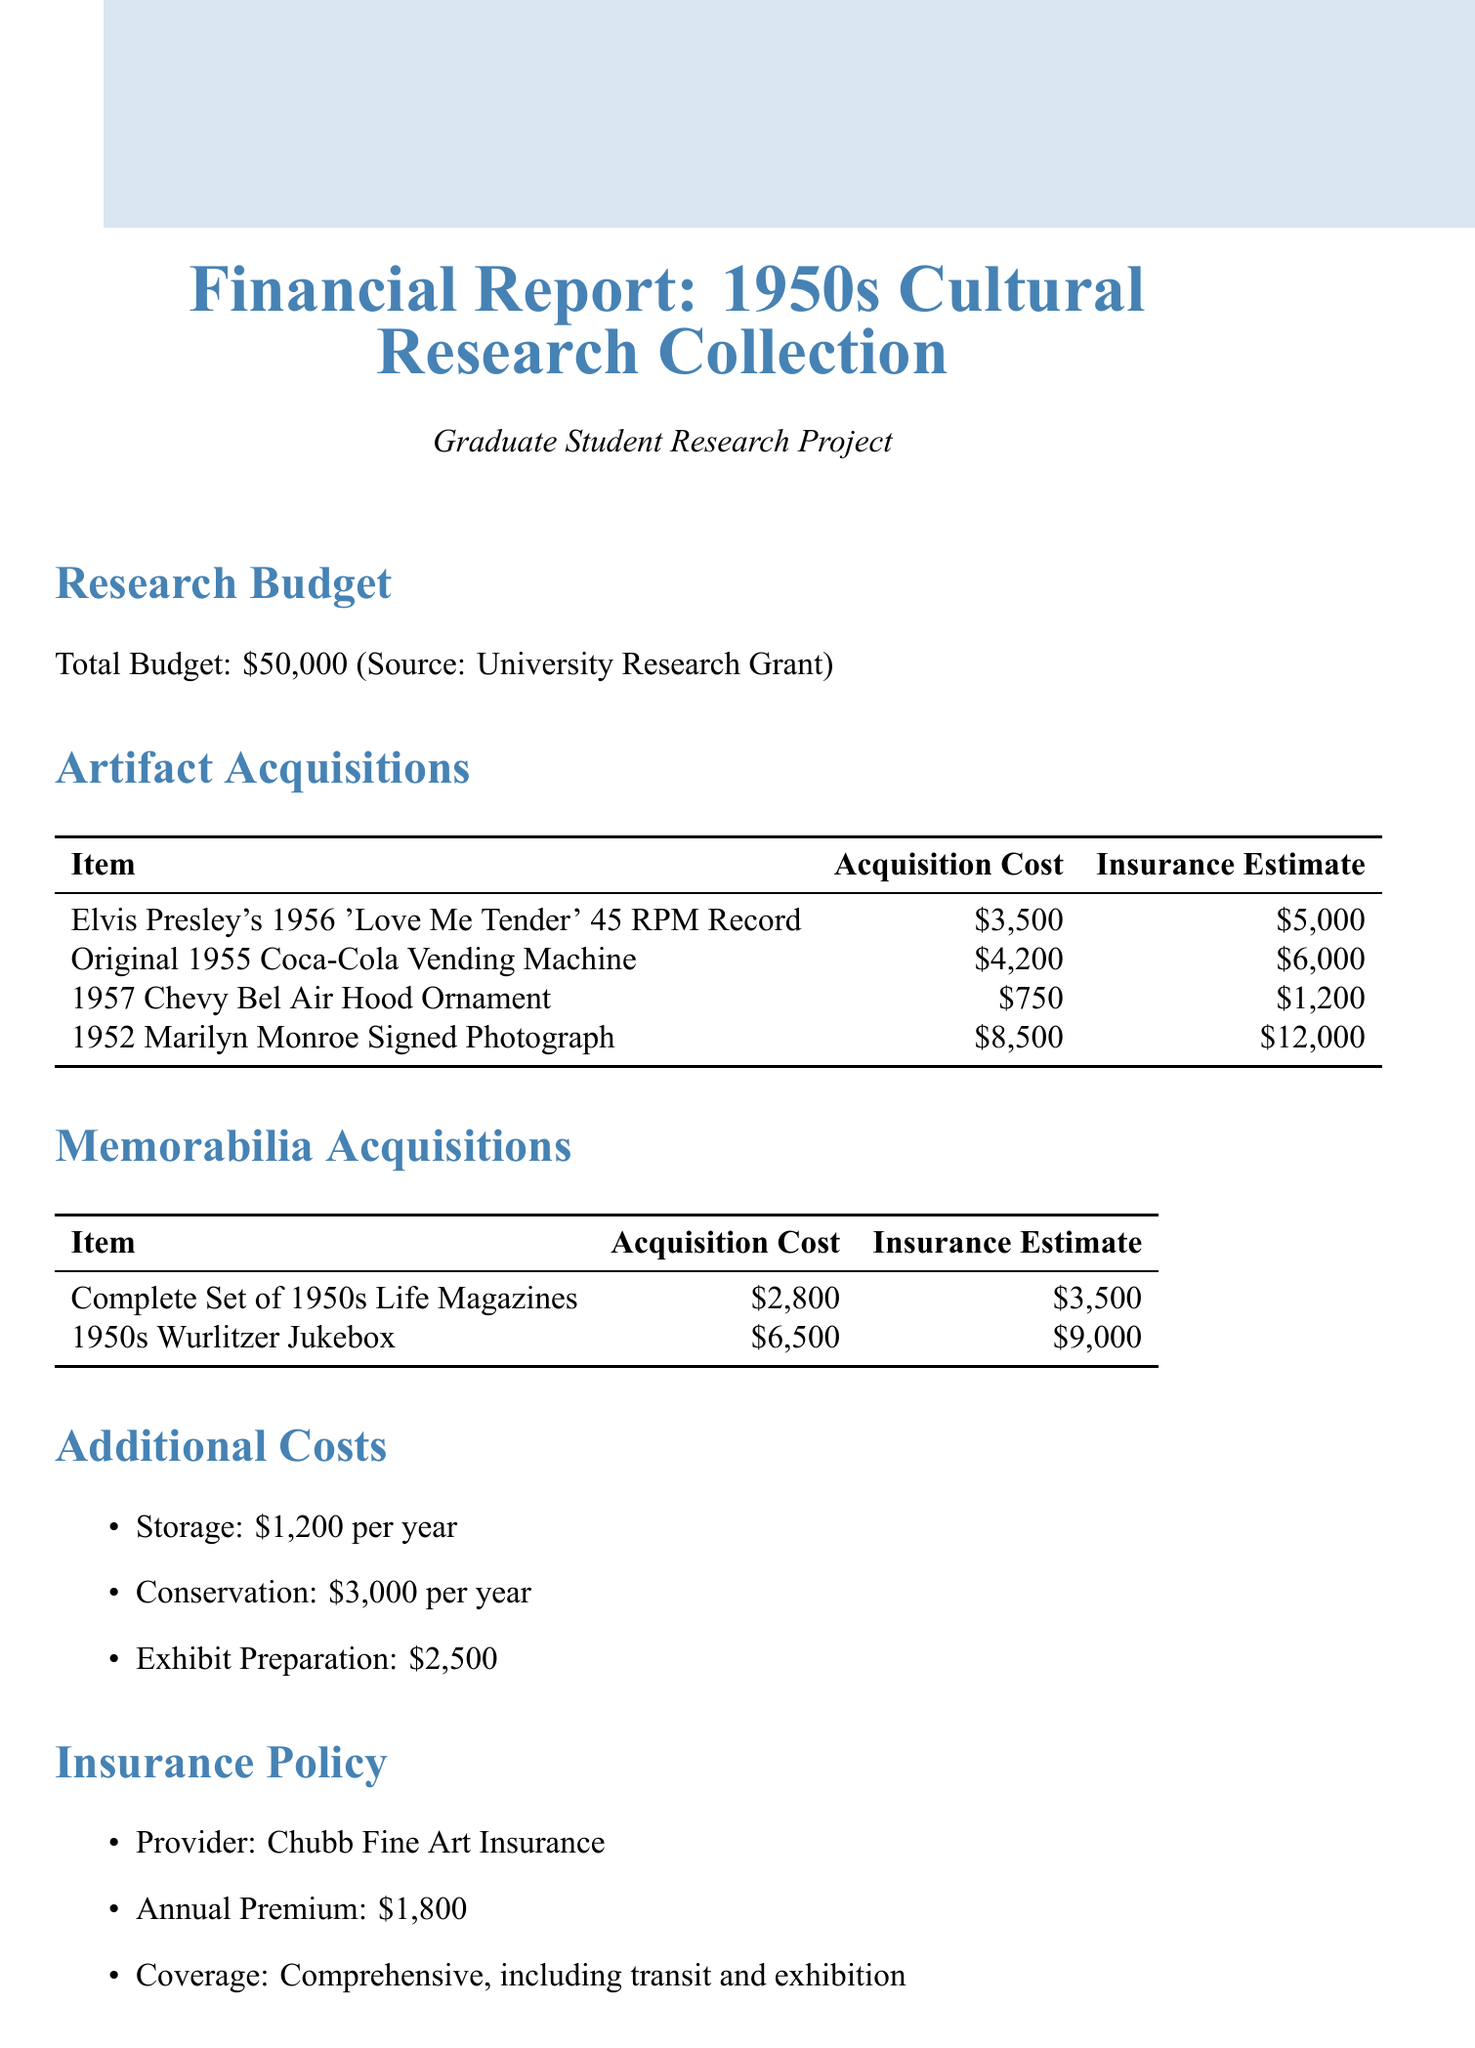what is the total research budget? The total research budget is specified in the document, which is $50,000.
Answer: $50,000 who is the insurance provider? The document states the insurance provider as Chubb Fine Art Insurance.
Answer: Chubb Fine Art Insurance what is the acquisition cost of the Marilyn Monroe signed photograph? The acquisition cost for the 1952 Marilyn Monroe Signed Photograph is detailed in the table.
Answer: $8,500 how much is the annual storage cost? The document lists the annual storage cost under additional costs.
Answer: $1,200 per year which artifact has the highest acquisition cost? The document lists the acquisition costs of all artifacts, the highest being for the Marilyn Monroe signed photograph.
Answer: $8,500 what is the insurance estimate for the Wurlitzer Jukebox? The insurance estimate for the 1950s Wurlitzer Jukebox can be found in the memorabilia acquisitions section.
Answer: $9,000 how many artifacts are listed in the document? By counting the items listed in the artifact acquisitions section, the total is determined.
Answer: 4 what is the total insurance estimate for all artifacts? The total insurance estimate is the sum of individual insurance estimates stated in the document.
Answer: $27,400 what are the acquisition sources mentioned? The acquisition sources are outlined in the document as a list.
Answer: Sotheby's Auctions, Heritage Auctions, Private Collectors, Antique Roadshow Discoveries 